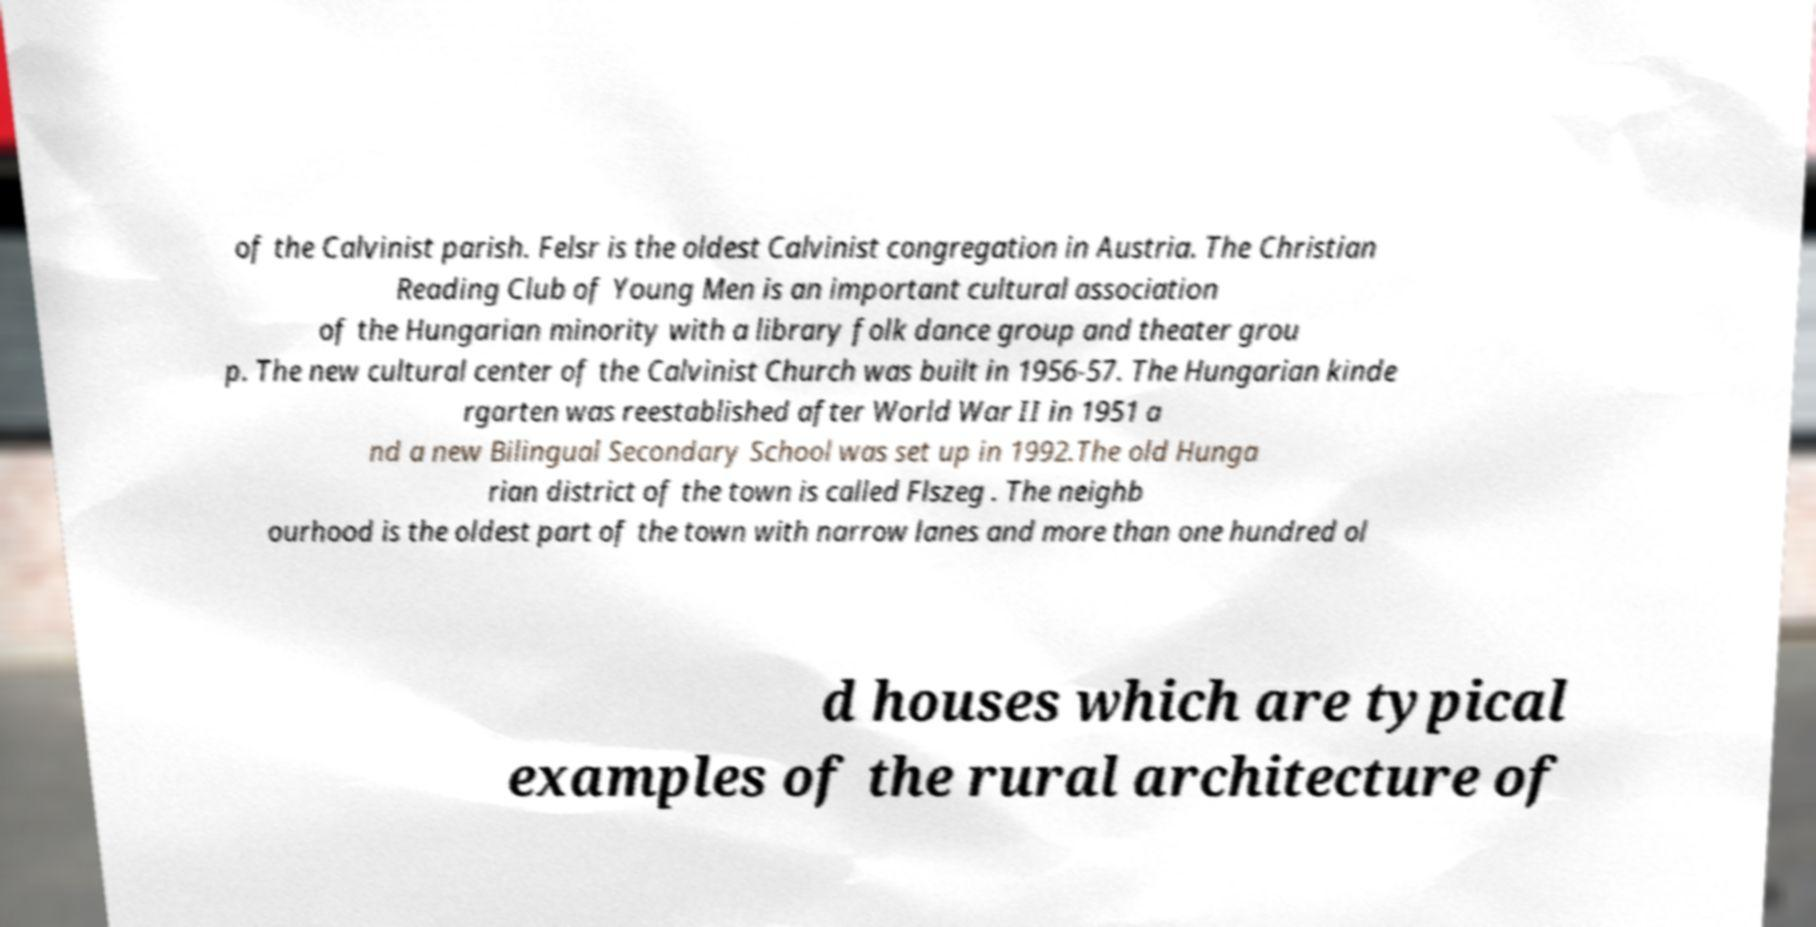There's text embedded in this image that I need extracted. Can you transcribe it verbatim? of the Calvinist parish. Felsr is the oldest Calvinist congregation in Austria. The Christian Reading Club of Young Men is an important cultural association of the Hungarian minority with a library folk dance group and theater grou p. The new cultural center of the Calvinist Church was built in 1956-57. The Hungarian kinde rgarten was reestablished after World War II in 1951 a nd a new Bilingual Secondary School was set up in 1992.The old Hunga rian district of the town is called Flszeg . The neighb ourhood is the oldest part of the town with narrow lanes and more than one hundred ol d houses which are typical examples of the rural architecture of 